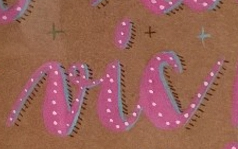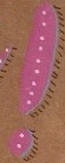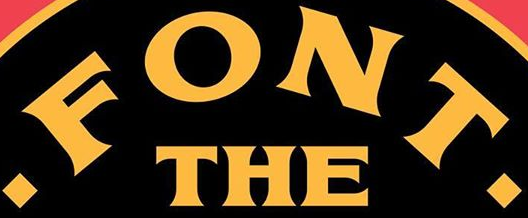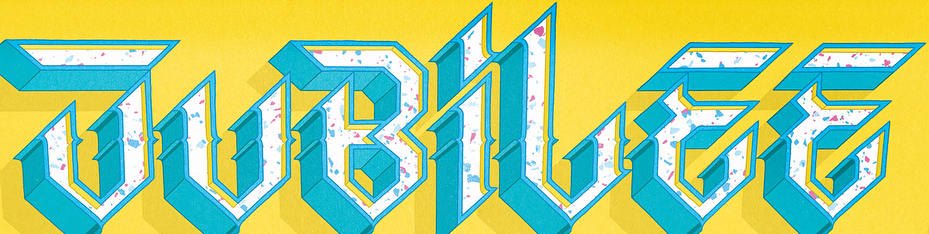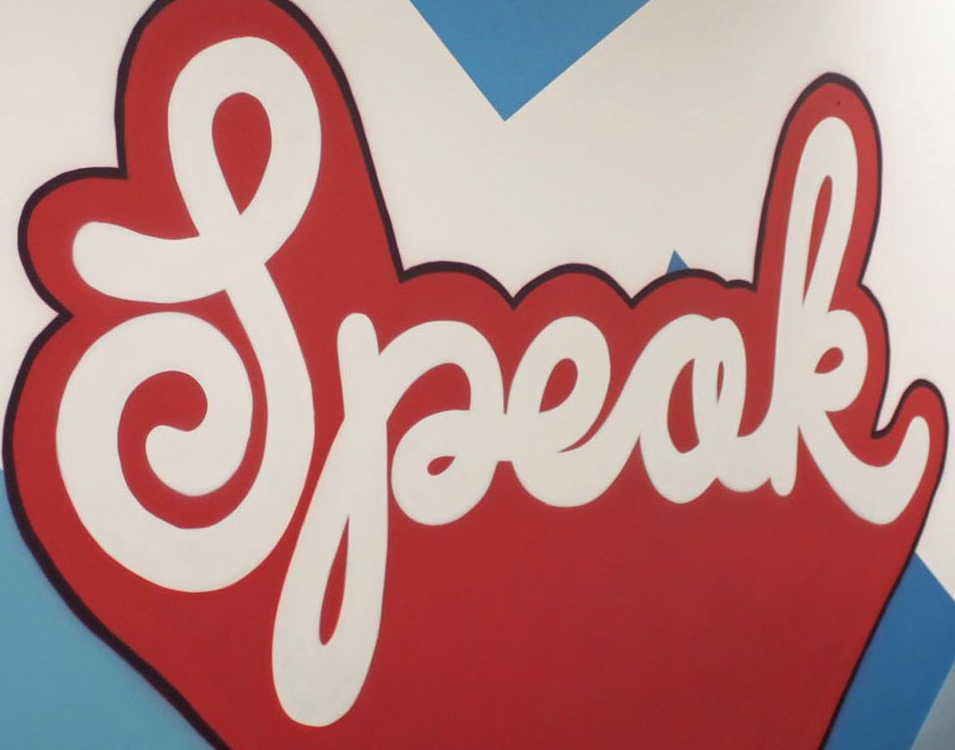Read the text content from these images in order, separated by a semicolon. vic; !; .FONT.; JUBiLEE; Speak 